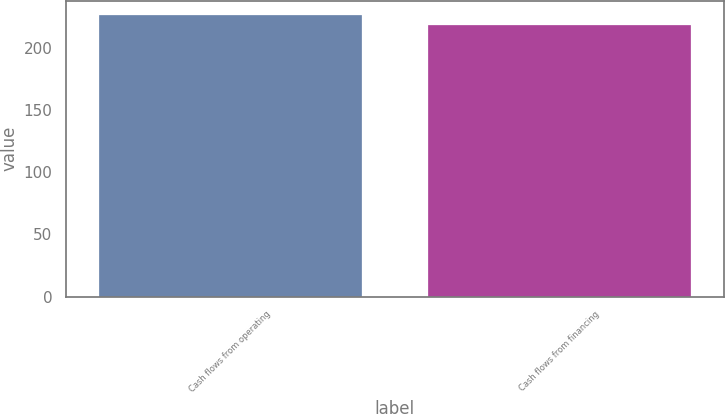<chart> <loc_0><loc_0><loc_500><loc_500><bar_chart><fcel>Cash flows from operating<fcel>Cash flows from financing<nl><fcel>226.6<fcel>219<nl></chart> 